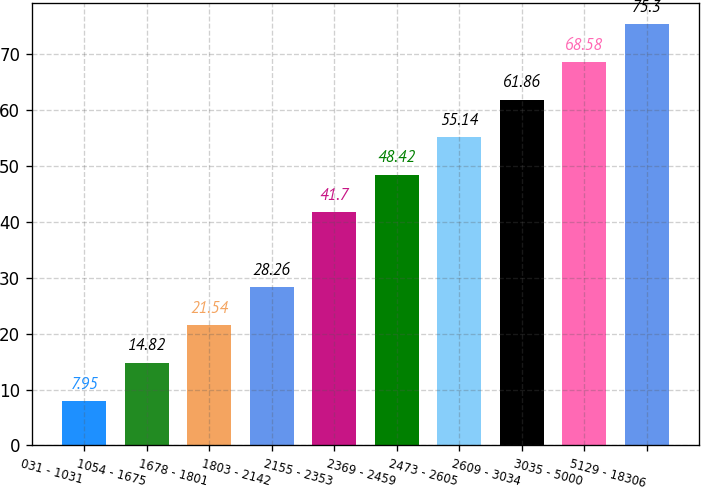Convert chart. <chart><loc_0><loc_0><loc_500><loc_500><bar_chart><fcel>031 - 1031<fcel>1054 - 1675<fcel>1678 - 1801<fcel>1803 - 2142<fcel>2155 - 2353<fcel>2369 - 2459<fcel>2473 - 2605<fcel>2609 - 3034<fcel>3035 - 5000<fcel>5129 - 18306<nl><fcel>7.95<fcel>14.82<fcel>21.54<fcel>28.26<fcel>41.7<fcel>48.42<fcel>55.14<fcel>61.86<fcel>68.58<fcel>75.3<nl></chart> 